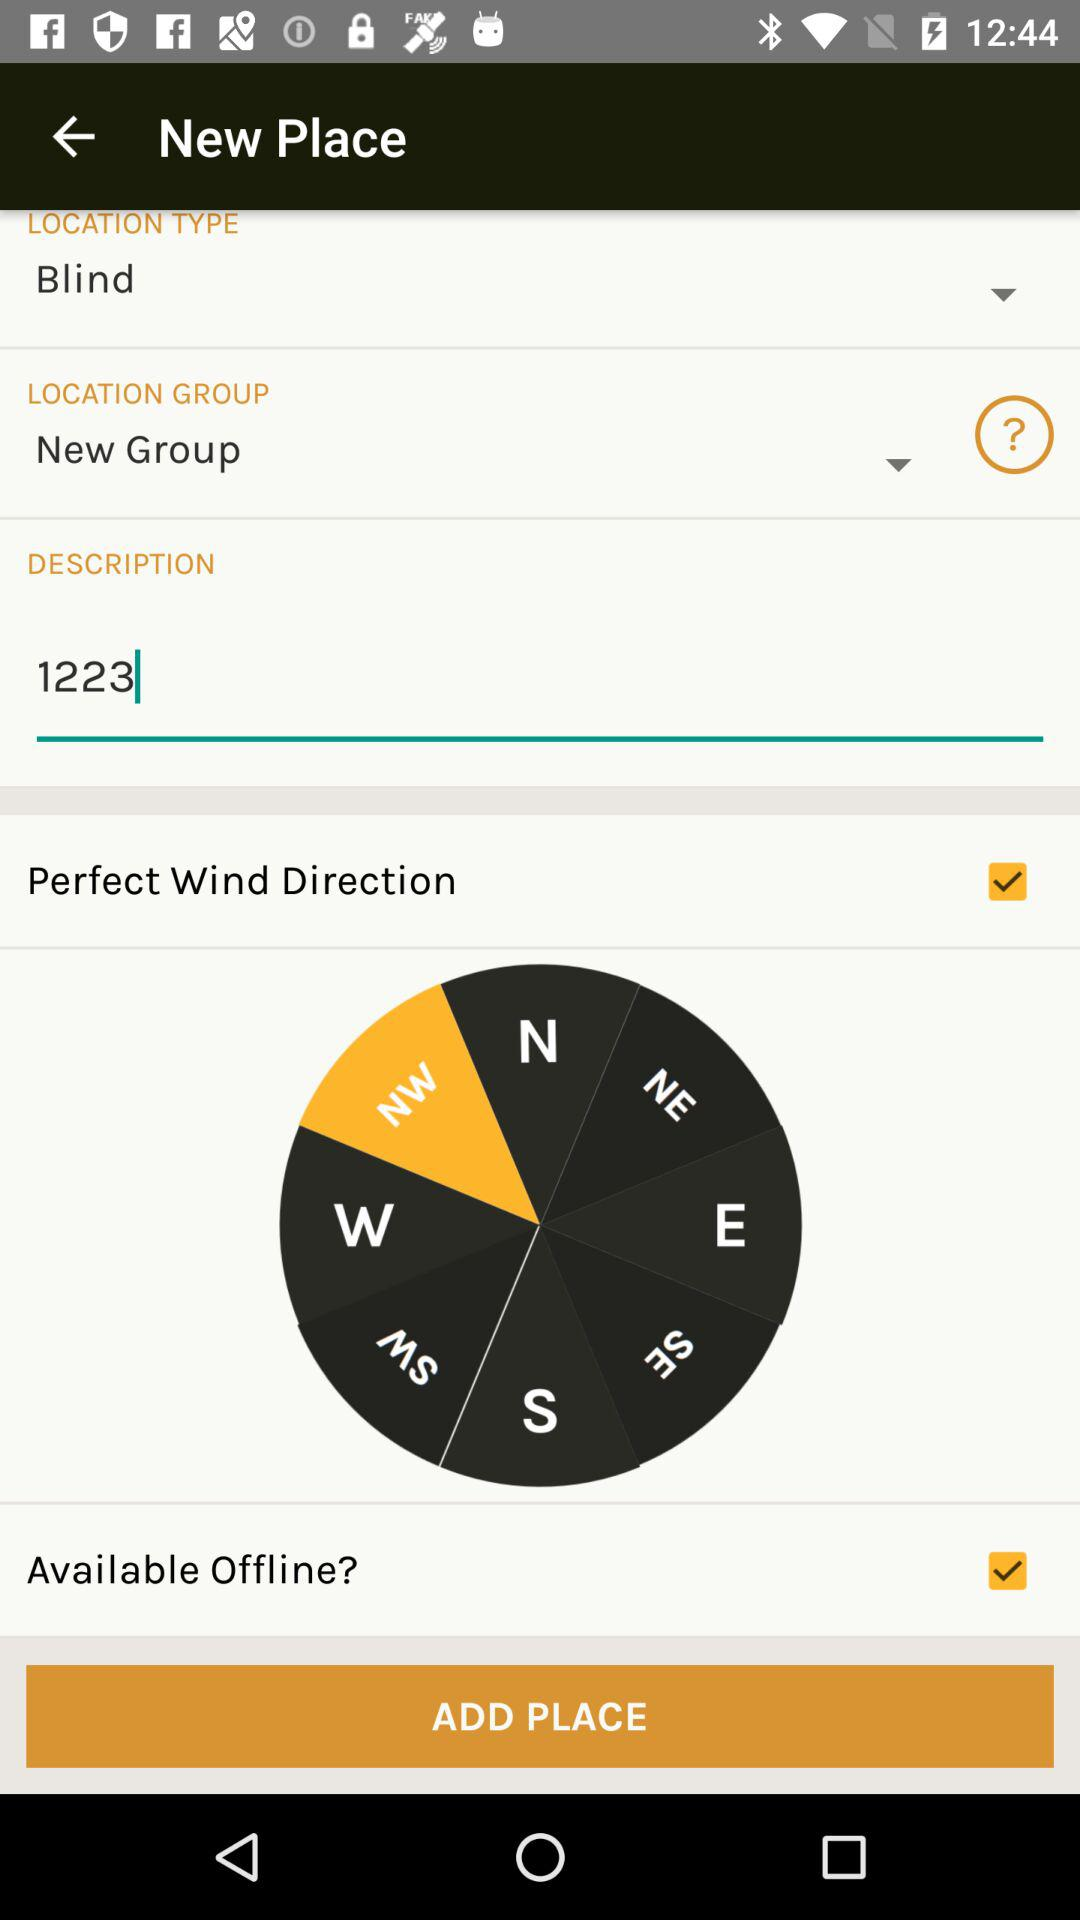What is the location type? The location type is "Blind". 